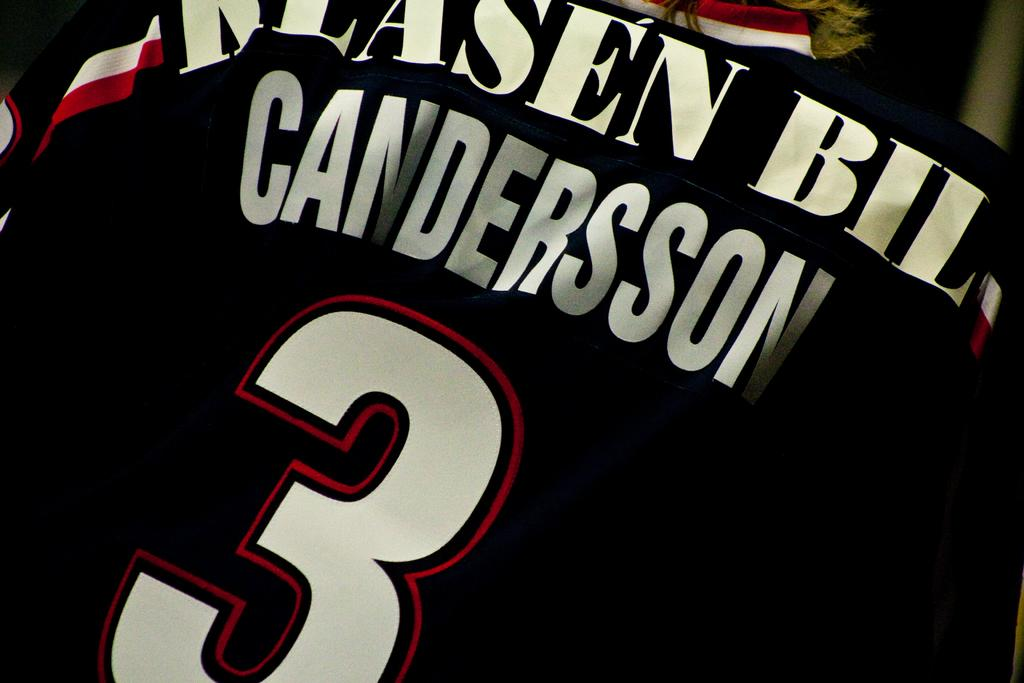Provide a one-sentence caption for the provided image. A black sports jersey with the number 3 and the name Candersson written on it. 